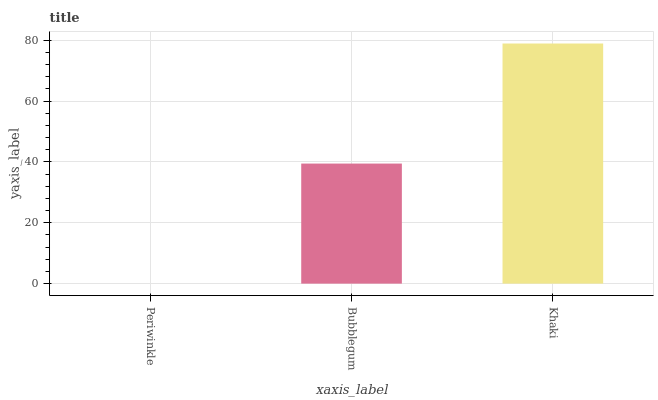Is Bubblegum the minimum?
Answer yes or no. No. Is Bubblegum the maximum?
Answer yes or no. No. Is Bubblegum greater than Periwinkle?
Answer yes or no. Yes. Is Periwinkle less than Bubblegum?
Answer yes or no. Yes. Is Periwinkle greater than Bubblegum?
Answer yes or no. No. Is Bubblegum less than Periwinkle?
Answer yes or no. No. Is Bubblegum the high median?
Answer yes or no. Yes. Is Bubblegum the low median?
Answer yes or no. Yes. Is Periwinkle the high median?
Answer yes or no. No. Is Periwinkle the low median?
Answer yes or no. No. 